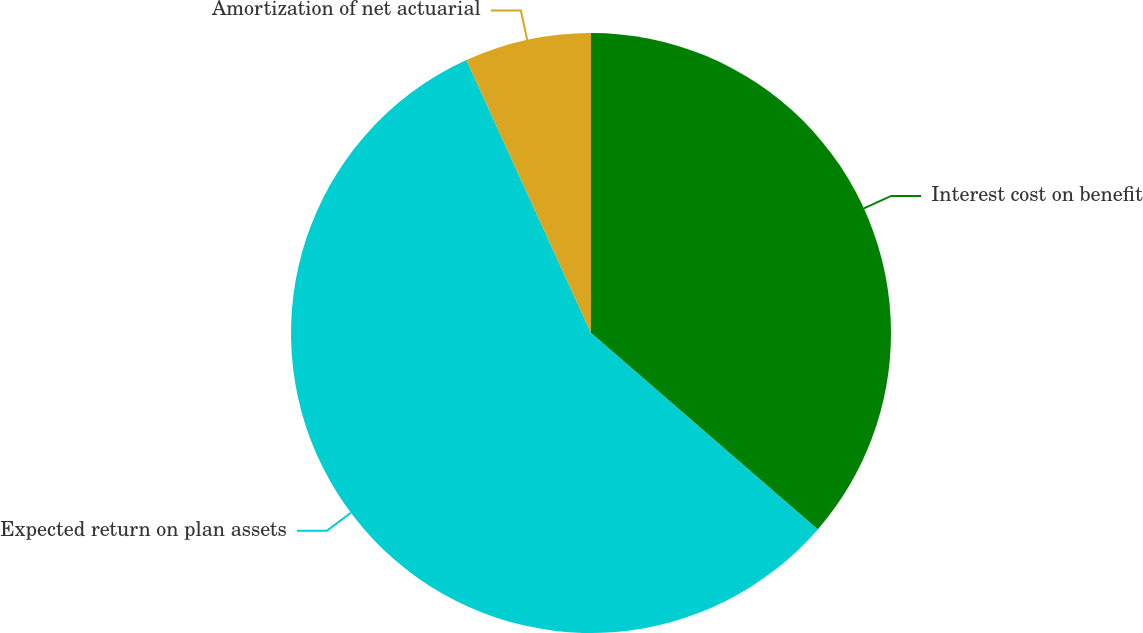Convert chart. <chart><loc_0><loc_0><loc_500><loc_500><pie_chart><fcel>Interest cost on benefit<fcel>Expected return on plan assets<fcel>Amortization of net actuarial<nl><fcel>36.36%<fcel>56.82%<fcel>6.82%<nl></chart> 